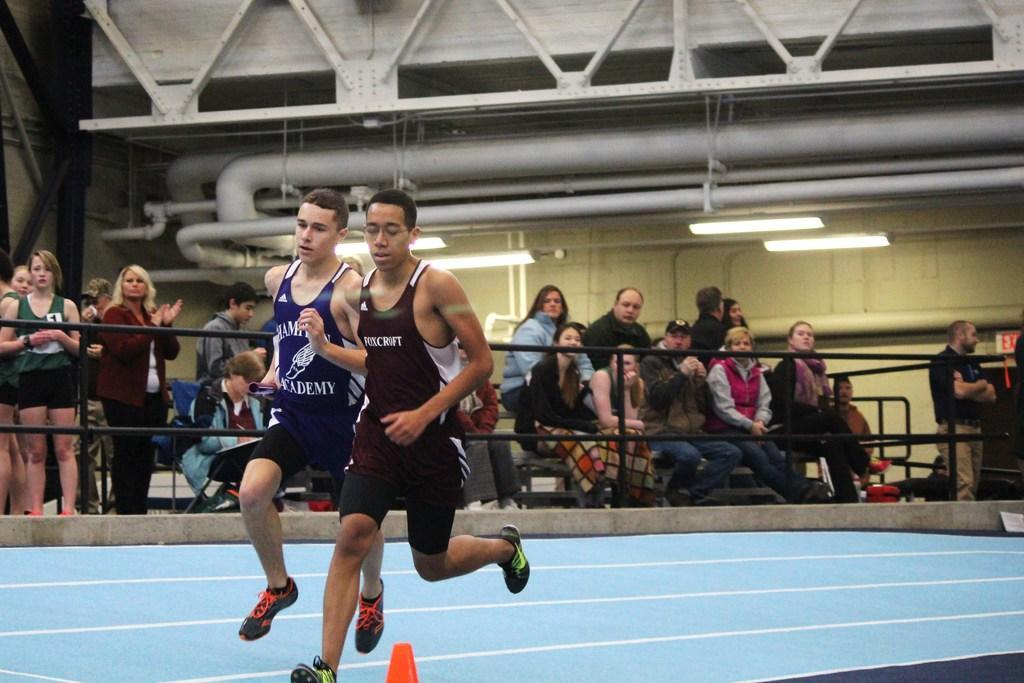Describe this image in one or two sentences. In this image there are two men running on the racing track, there is an object towards the bottom of the image, there are group of audience sitting, there are persons standing, there is the wall, there are lights, there are pipes. 